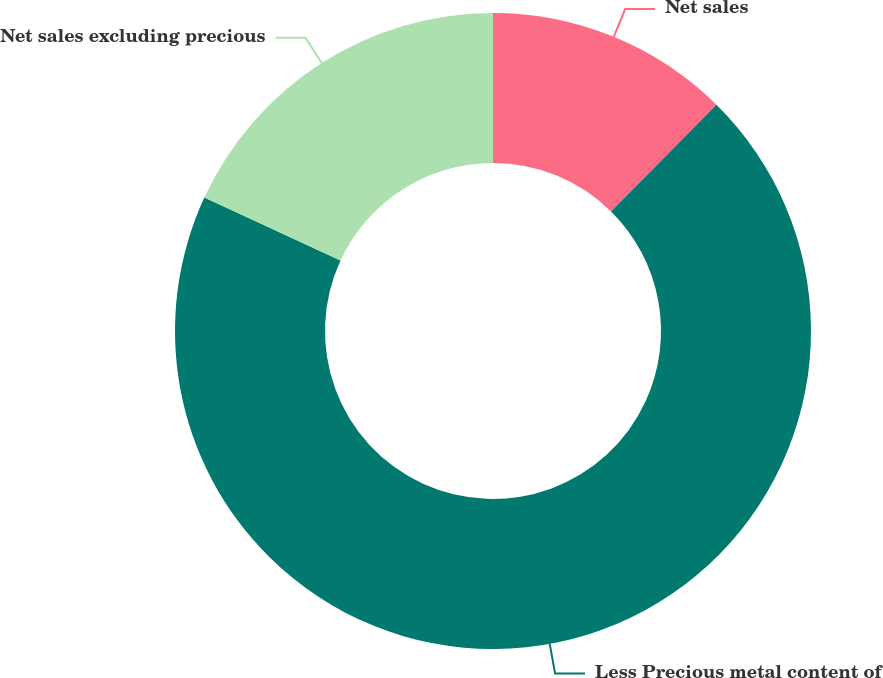Convert chart. <chart><loc_0><loc_0><loc_500><loc_500><pie_chart><fcel>Net sales<fcel>Less Precious metal content of<fcel>Net sales excluding precious<nl><fcel>12.4%<fcel>69.5%<fcel>18.11%<nl></chart> 